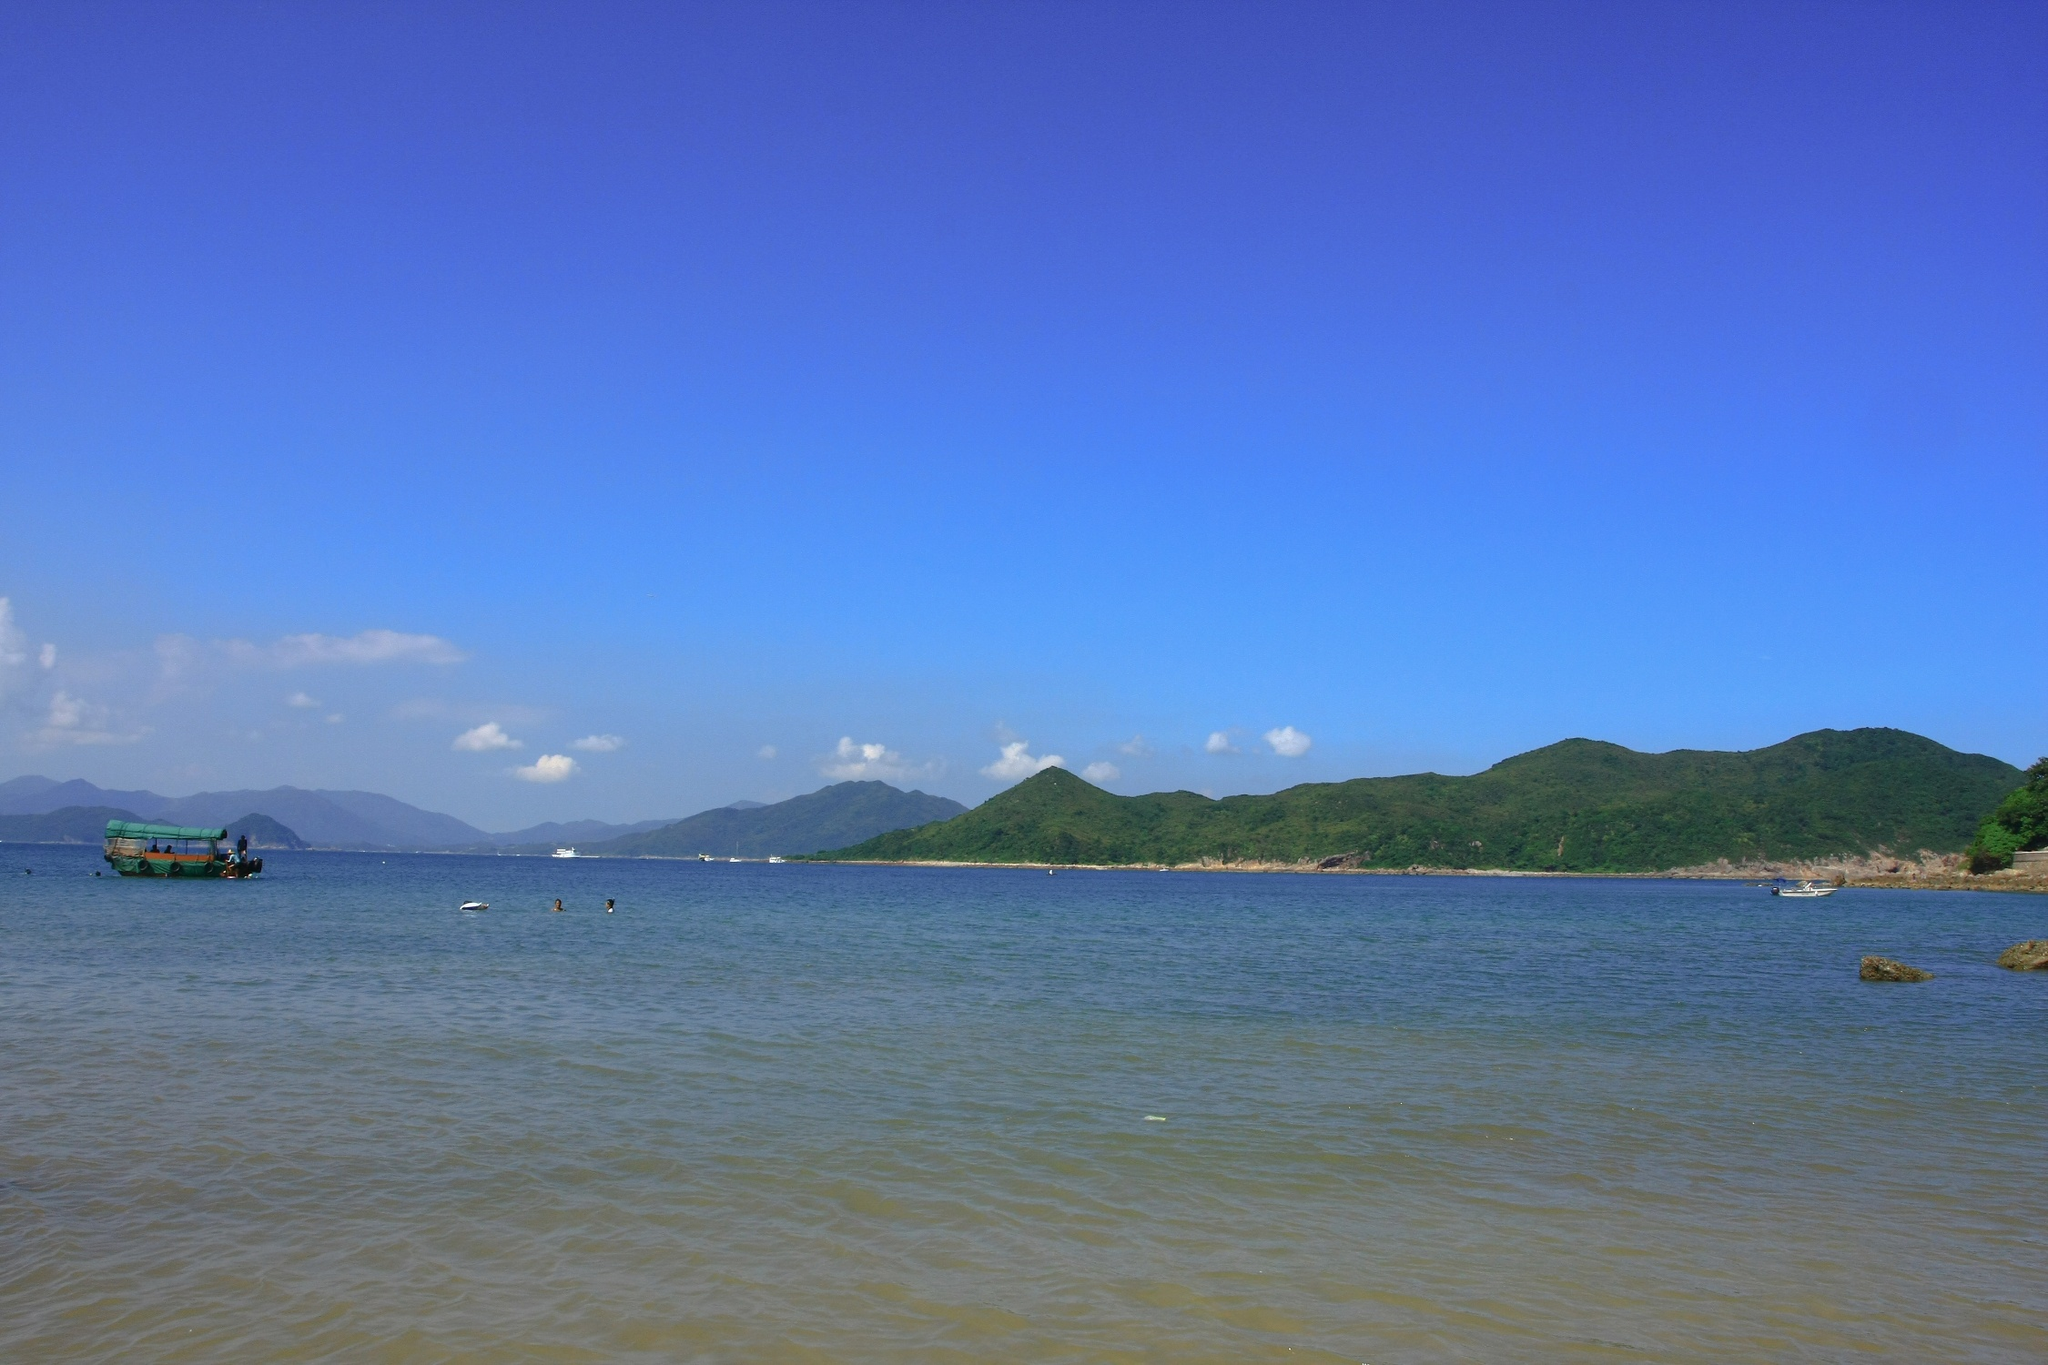What is this photo about? The image captures a tranquil coastal scene where the pristine blue waters of the ocean seamlessly merge with the bright, azure sky at the distant horizon. In the forefront, a small green boat, possibly used for fishing, adds a touch of human presence to this vast, serene seascape. The stillness of the water suggests it is a calm, peaceful day perfect for a leisurely exploration of the sea. From the shore, the image invites the viewer to gaze outwards, capturing the sense of depth and expansiveness. In the background, lush green mountains rise gracefully, their verdant hues providing a striking contrast to the blues of the ocean and sky. The vibrancy of the scene is further amplified by the ample daylight, making the colors pop in a visually stunning display. While there's no specific information readily available about the landmark 'sa_12147', more detailed context might help in identifying it. 